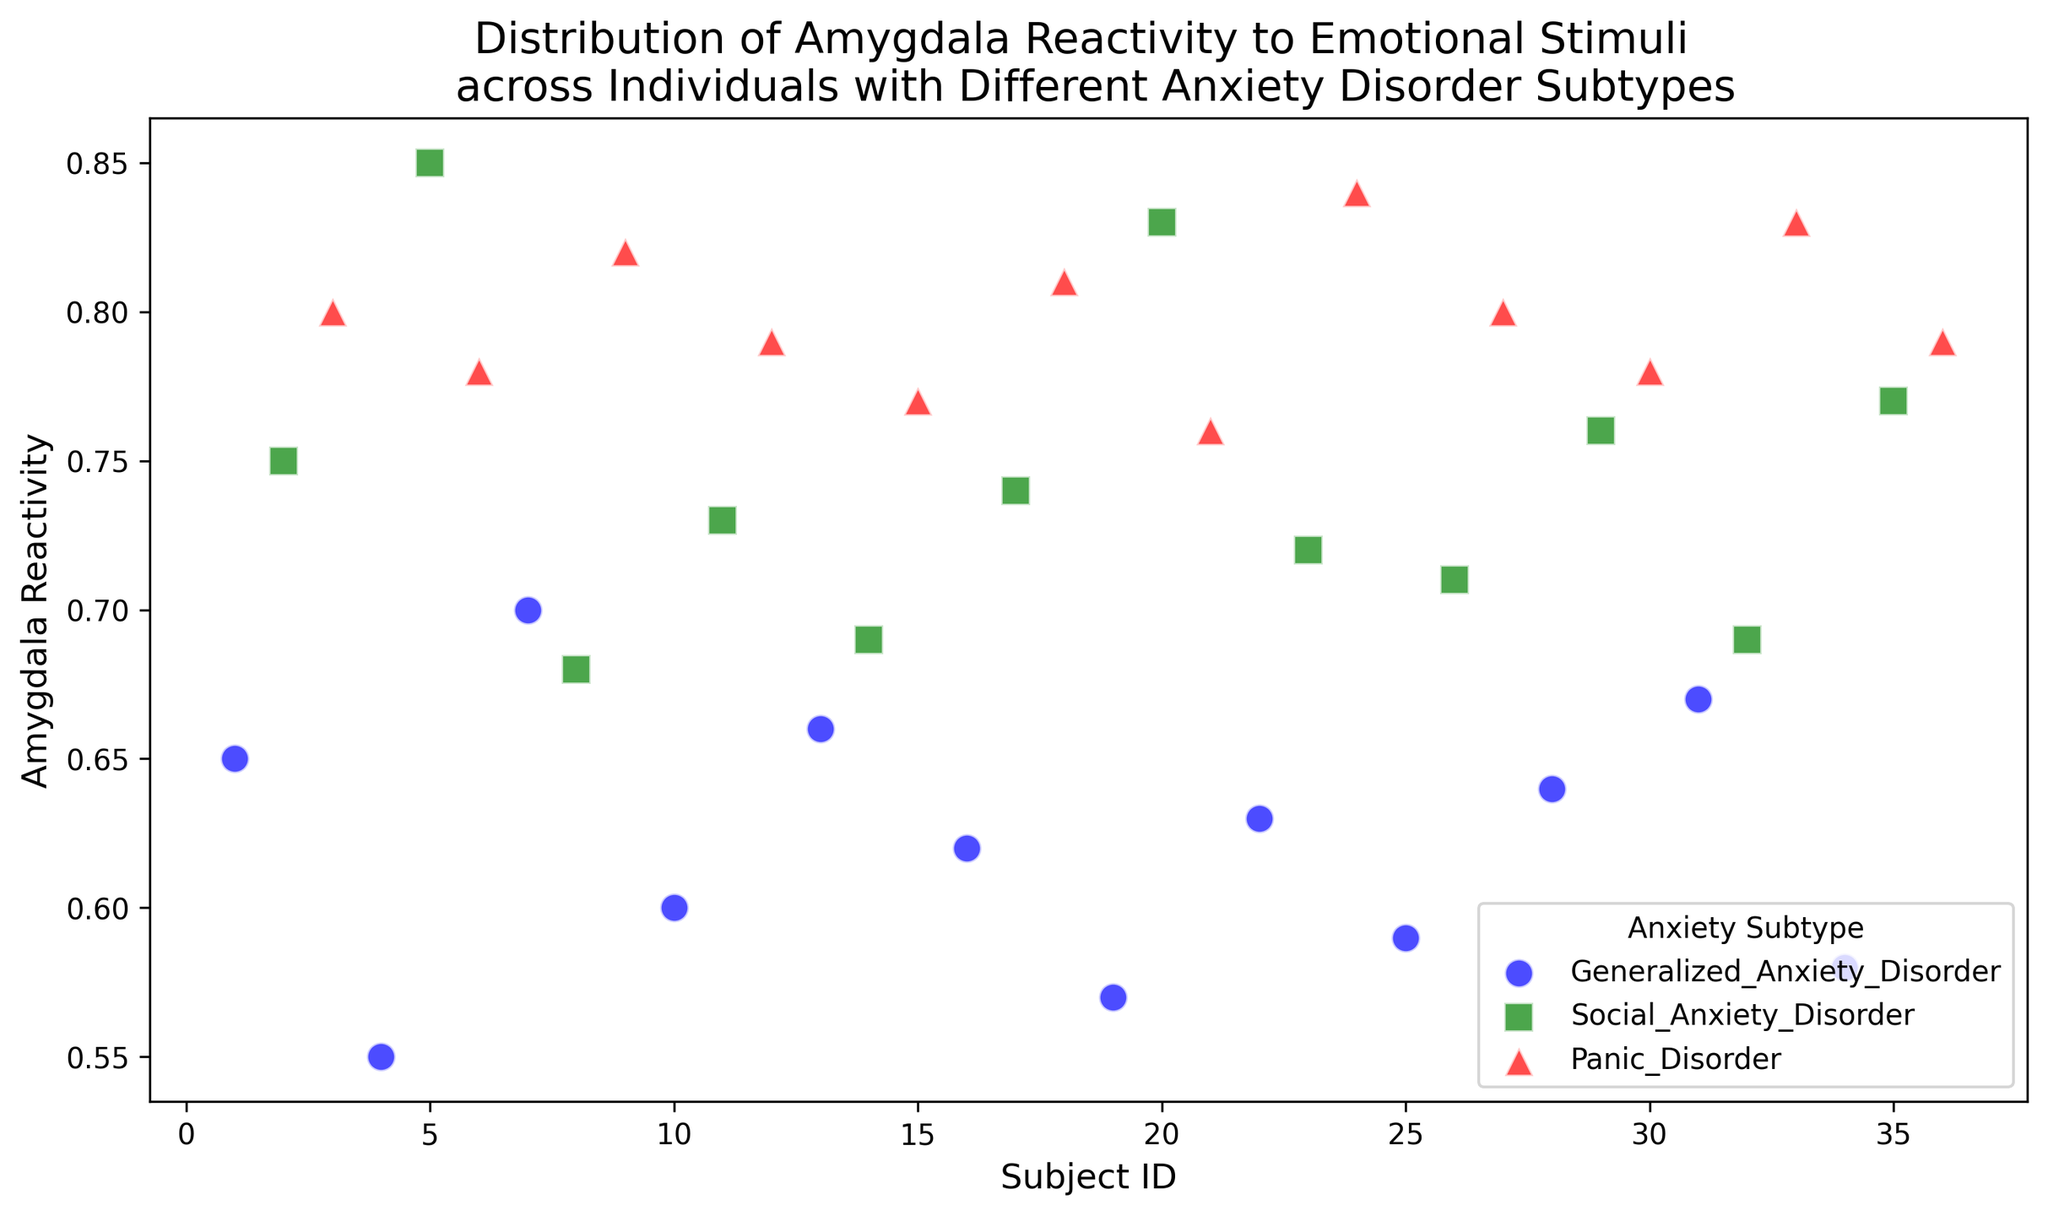What's the median value of Amygdala Reactivity for individuals with Generalized Anxiety Disorder? First, identify the data points for Generalized Anxiety Disorder. The Amygdala Reactivity values are [0.65, 0.55, 0.70, 0.60, 0.66, 0.62, 0.57, 0.63, 0.59, 0.64, 0.67, 0.58]. Sort these values to get [0.55, 0.57, 0.58, 0.59, 0.60, 0.62, 0.63, 0.64, 0.65, 0.66, 0.67, 0.70]. The median is the average of the 6th and 7th values: (0.62 + 0.63)/2 = 0.625
Answer: 0.625 Which anxiety subtype has the highest overall Amygdala Reactivity? Compare the maximum Amygdala Reactivity values for each subtype: Generalized Anxiety Disorder (0.70), Social Anxiety Disorder (0.85), and Panic Disorder (0.84). The highest value among these is 0.85 for Social Anxiety Disorder
Answer: Social Anxiety Disorder Are there more individuals with Generalized Anxiety Disorder or Panic Disorder? Count the number of data points for each subtype: Generalized Anxiety Disorder has 12 individuals, and Panic Disorder has 12 individuals. Since both counts are equal, no subtype has more individuals
Answer: Equal What is the average Amygdala Reactivity value for individuals with Panic Disorder? Identify the data points for Panic Disorder. The Amygdala Reactivity values are [0.80, 0.78, 0.82, 0.79, 0.77, 0.81, 0.76, 0.84, 0.80, 0.78, 0.83, 0.79]. Sum these values to get 9.57, and then divide by the number of data points (12). Thus, the average is 9.57/12 ≈ 0.7975
Answer: 0.7975 Which color represents individuals with Social Anxiety Disorder? By looking at the legend in the figure, the color green is associated with Social Anxiety Disorder
Answer: green Are the data points for Social Anxiety Disorder more spread out than those for Generalized Anxiety Disorder? Assess the range of Amygdala Reactivity values for both subtypes: Social Anxiety Disorder ranges from 0.68 to 0.85, giving a range of 0.17. Generalized Anxiety Disorder ranges from 0.55 to 0.70, giving a range of 0.15. Since 0.17 is greater than 0.15, the data points for Social Anxiety Disorder are more spread out
Answer: Yes What is the difference in average Amygdala Reactivity between Generalized Anxiety Disorder and Social Anxiety Disorder? Calculate the average Amygdala Reactivity for both subtypes: Generalized Anxiety Disorder averages (sum of [0.65, 0.55, 0.70, 0.60, 0.66, 0.62, 0.57, 0.63, 0.59, 0.64, 0.67, 0.58] divided by 12) ≈ 0.6217, and Social Anxiety Disorder averages (sum of [0.75, 0.85, 0.68, 0.73, 0.74, 0.83, 0.72, 0.71, 0.76, 0.69, 0.77] divided by 12) ≈ 0.7433. The difference is 0.7433 - 0.6217 ≈ 0.121
Answer: 0.121 